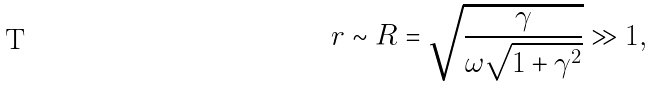Convert formula to latex. <formula><loc_0><loc_0><loc_500><loc_500>r \sim R = \sqrt { \frac { \gamma } { \omega \sqrt { 1 + \gamma ^ { 2 } } } } \gg 1 ,</formula> 